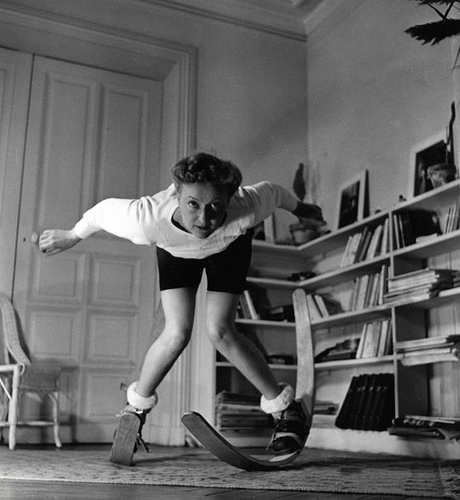<image>What sport is she playing? I don't know what sport she is playing. It could be skiing, indoor skiing, gymnastics or exercise. What sport is she playing? I'm not sure what sport she is playing. It could be skiing, indoor skiing, or gymnastics. 